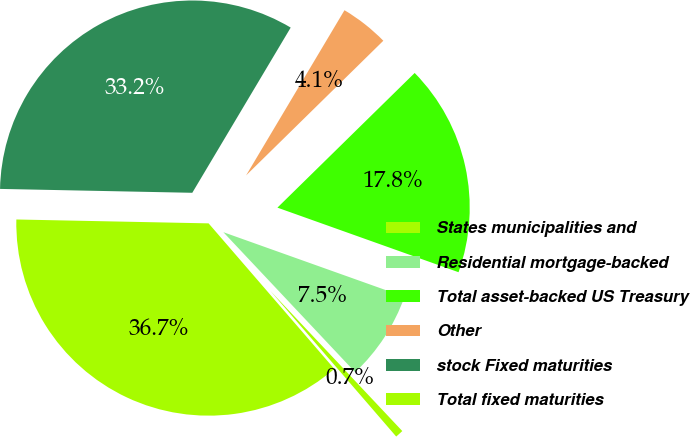Convert chart to OTSL. <chart><loc_0><loc_0><loc_500><loc_500><pie_chart><fcel>States municipalities and<fcel>Residential mortgage-backed<fcel>Total asset-backed US Treasury<fcel>Other<fcel>stock Fixed maturities<fcel>Total fixed maturities<nl><fcel>0.68%<fcel>7.53%<fcel>17.8%<fcel>4.1%<fcel>33.23%<fcel>36.66%<nl></chart> 